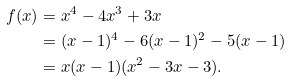Convert formula to latex. <formula><loc_0><loc_0><loc_500><loc_500>f ( x ) & = x ^ { 4 } - 4 x ^ { 3 } + 3 x \\ & = ( x - 1 ) ^ { 4 } - 6 ( x - 1 ) ^ { 2 } - 5 ( x - 1 ) \\ & = x ( x - 1 ) ( x ^ { 2 } - 3 x - 3 ) .</formula> 